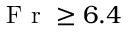Convert formula to latex. <formula><loc_0><loc_0><loc_500><loc_500>F r \geq 6 . 4</formula> 